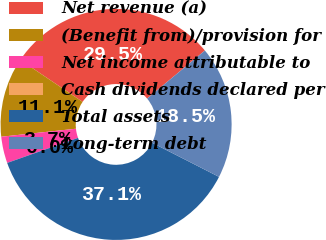<chart> <loc_0><loc_0><loc_500><loc_500><pie_chart><fcel>Net revenue (a)<fcel>(Benefit from)/provision for<fcel>Net income attributable to<fcel>Cash dividends declared per<fcel>Total assets<fcel>Long-term debt<nl><fcel>29.52%<fcel>11.13%<fcel>3.71%<fcel>0.0%<fcel>37.09%<fcel>18.55%<nl></chart> 